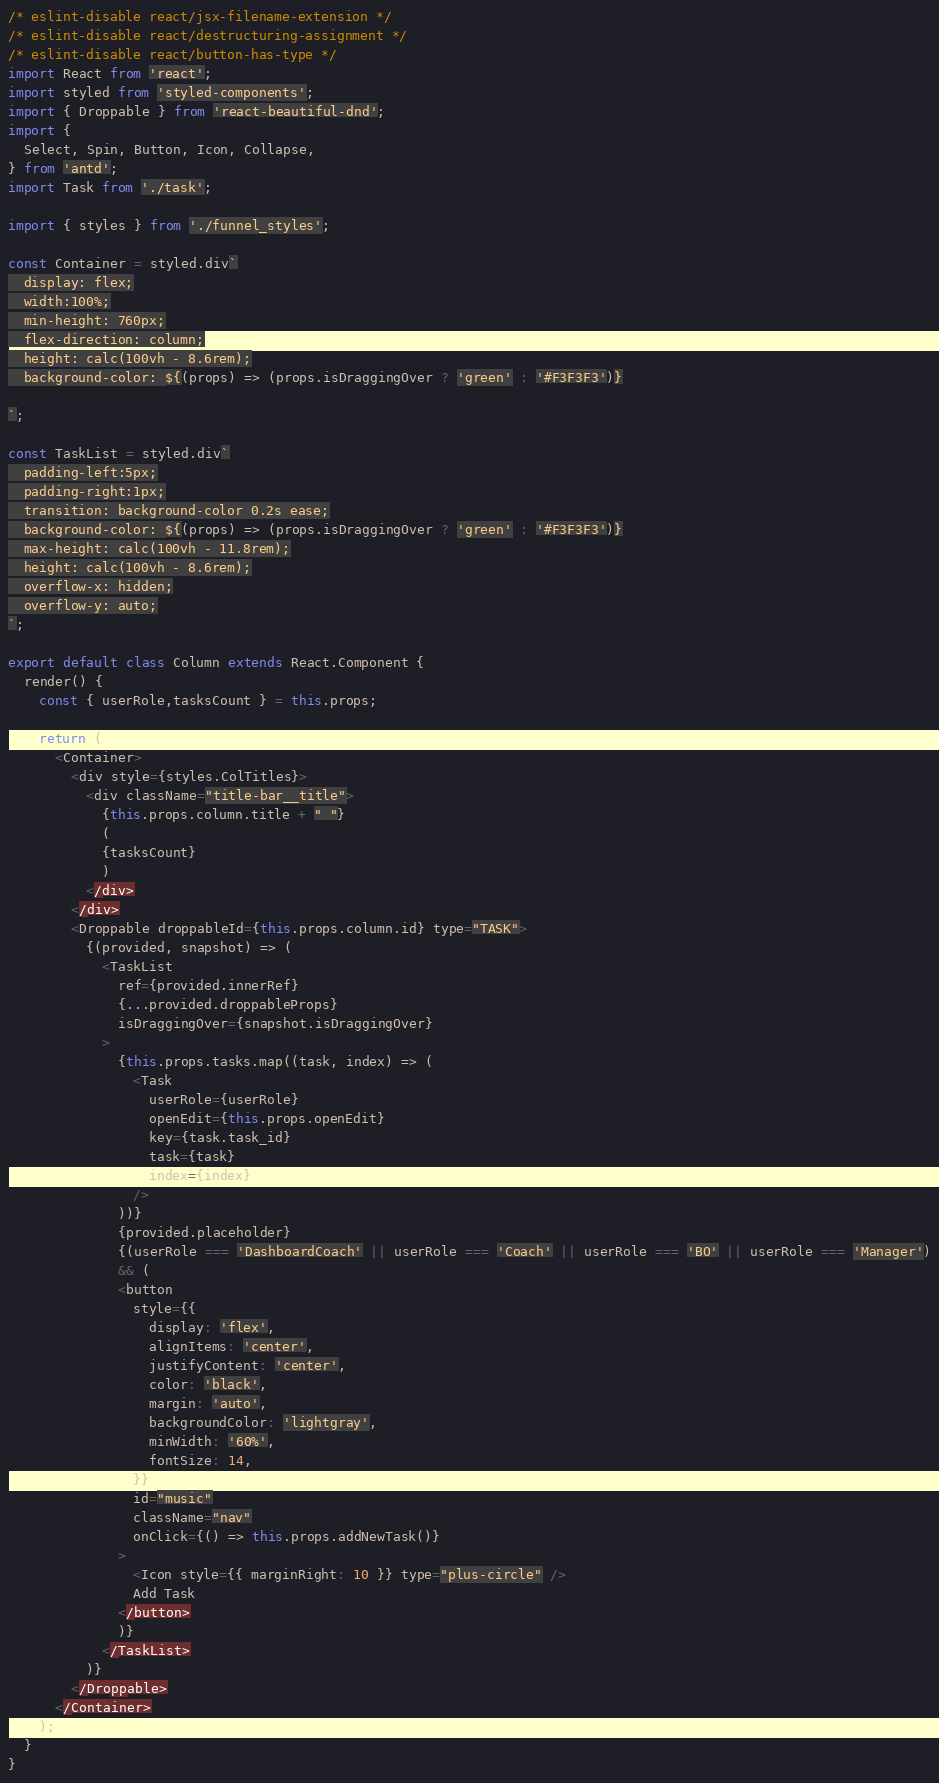<code> <loc_0><loc_0><loc_500><loc_500><_JavaScript_>/* eslint-disable react/jsx-filename-extension */
/* eslint-disable react/destructuring-assignment */
/* eslint-disable react/button-has-type */
import React from 'react';
import styled from 'styled-components';
import { Droppable } from 'react-beautiful-dnd';
import {
  Select, Spin, Button, Icon, Collapse,
} from 'antd';
import Task from './task';

import { styles } from './funnel_styles';

const Container = styled.div`
  display: flex;
  width:100%;
  min-height: 760px;
  flex-direction: column;
  height: calc(100vh - 8.6rem);
  background-color: ${(props) => (props.isDraggingOver ? 'green' : '#F3F3F3')}

`;

const TaskList = styled.div`
  padding-left:5px;
  padding-right:1px;
  transition: background-color 0.2s ease;
  background-color: ${(props) => (props.isDraggingOver ? 'green' : '#F3F3F3')}
  max-height: calc(100vh - 11.8rem);
  height: calc(100vh - 8.6rem);
  overflow-x: hidden;
  overflow-y: auto;
`;

export default class Column extends React.Component {
  render() {
    const { userRole,tasksCount } = this.props;

    return (
      <Container>
        <div style={styles.ColTitles}>
          <div className="title-bar__title">
            {this.props.column.title + " "}
            (
            {tasksCount}
            )
          </div>
        </div>
        <Droppable droppableId={this.props.column.id} type="TASK">
          {(provided, snapshot) => (
            <TaskList
              ref={provided.innerRef}
              {...provided.droppableProps}
              isDraggingOver={snapshot.isDraggingOver}
            >
              {this.props.tasks.map((task, index) => (
                <Task
                  userRole={userRole}
                  openEdit={this.props.openEdit}
                  key={task.task_id}
                  task={task}
                  index={index}
                />
              ))}
              {provided.placeholder}
              {(userRole === 'DashboardCoach' || userRole === 'Coach' || userRole === 'BO' || userRole === 'Manager')
              && (
              <button
                style={{
                  display: 'flex',
                  alignItems: 'center',
                  justifyContent: 'center',
                  color: 'black',
                  margin: 'auto',
                  backgroundColor: 'lightgray',
                  minWidth: '60%',
                  fontSize: 14,
                }}
                id="music"
                className="nav"
                onClick={() => this.props.addNewTask()}
              >
                <Icon style={{ marginRight: 10 }} type="plus-circle" />
                Add Task
              </button>
              )}
            </TaskList>
          )}
        </Droppable>
      </Container>
    );
  }
}
</code> 